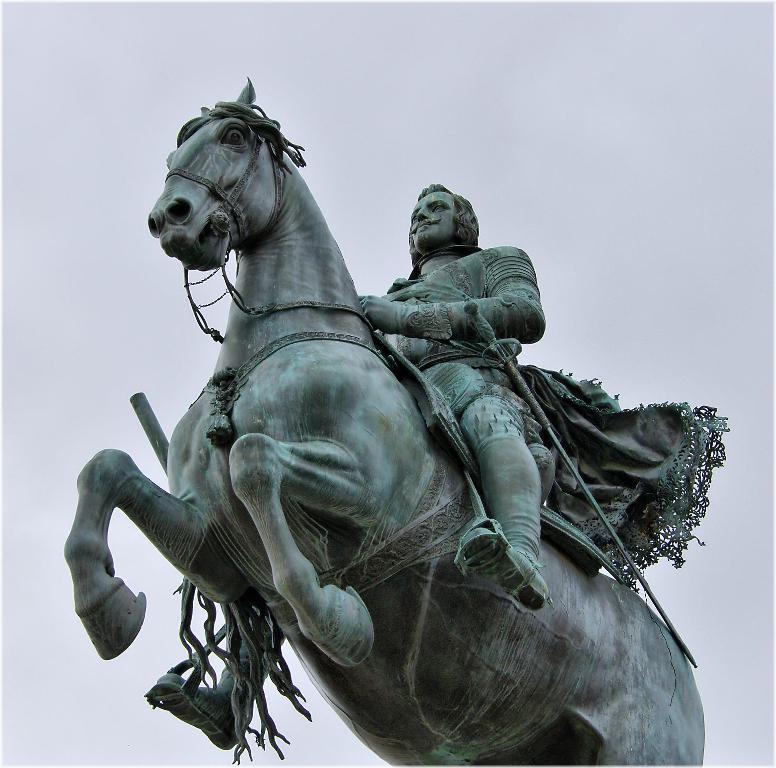Could you give a brief overview of what you see in this image? In this picture we can see statue of a horse and a man. 